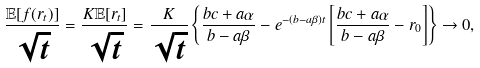<formula> <loc_0><loc_0><loc_500><loc_500>\frac { \mathbb { E } [ f ( r _ { t } ) ] } { \sqrt { t } } = \frac { K \mathbb { E } [ r _ { t } ] } { \sqrt { t } } = \frac { K } { \sqrt { t } } \left \{ \frac { b c + a \alpha } { b - a \beta } - e ^ { - ( b - a \beta ) t } \left [ \frac { b c + a \alpha } { b - a \beta } - r _ { 0 } \right ] \right \} \rightarrow 0 ,</formula> 